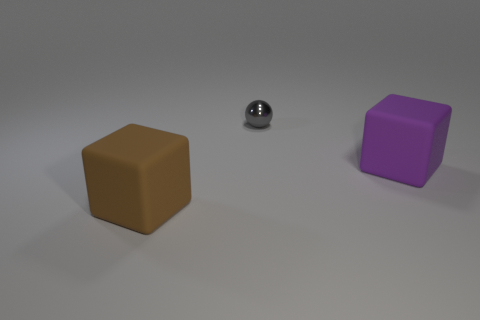Add 3 tiny shiny spheres. How many objects exist? 6 Subtract all spheres. How many objects are left? 2 Add 3 big brown cubes. How many big brown cubes exist? 4 Subtract 0 green spheres. How many objects are left? 3 Subtract all red rubber spheres. Subtract all rubber things. How many objects are left? 1 Add 3 purple cubes. How many purple cubes are left? 4 